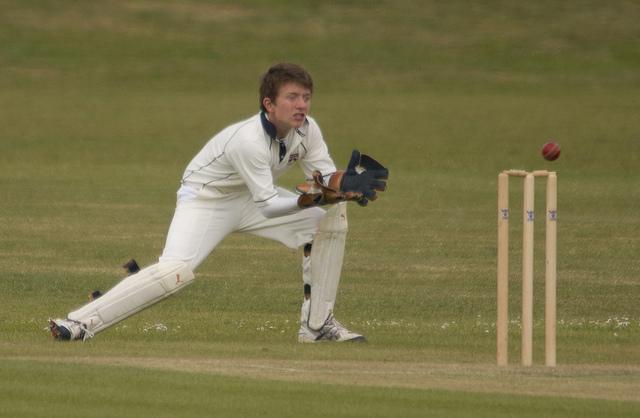How many of this man's feet are flat on the ground?
Concise answer only. 1. What game is being played?
Short answer required. Cricket. What sport is this person playing?
Concise answer only. Baseball. What sport is this?
Short answer required. Cricket. What color is the ball?
Give a very brief answer. Red. Do you see a fence?
Quick response, please. No. 